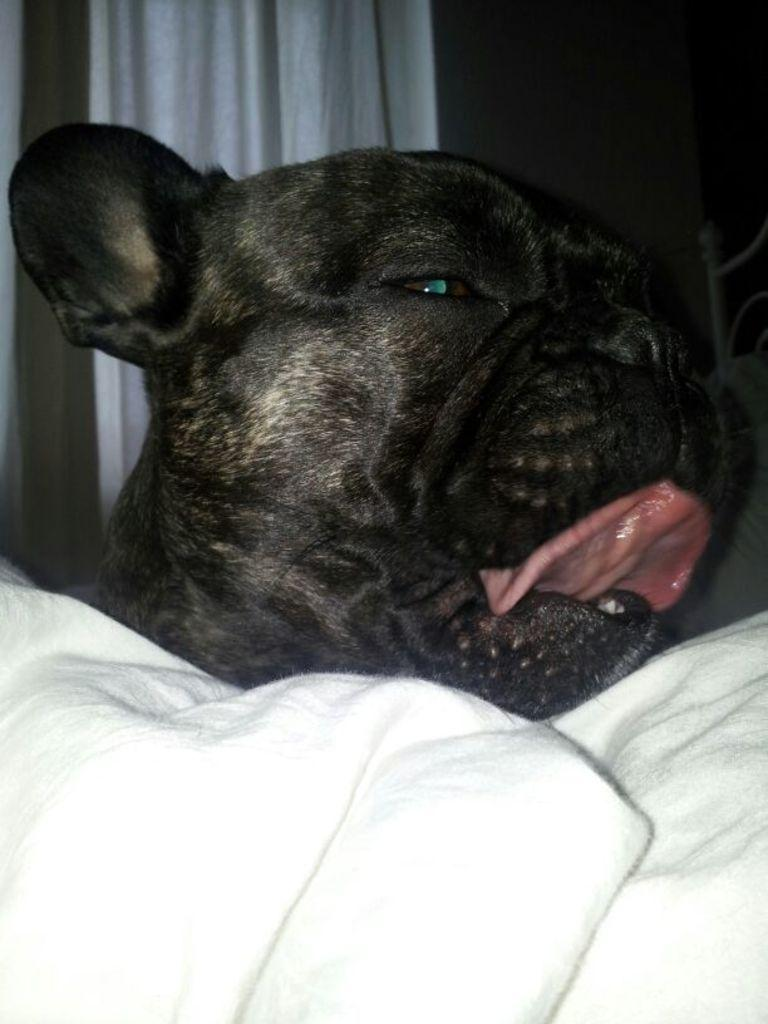What type of animal is in the image? There is a dog in the image. What is the color of the dog? The dog is black in color. What is covering the dog in the image? There is a white color blanket on the dog. What can be seen in the background of the image? There is a curtain and a wall in the background of the image. How many toes can be seen on the dog in the image? Dogs have paws, not toes, and the image does not show the dog's paws in detail. 